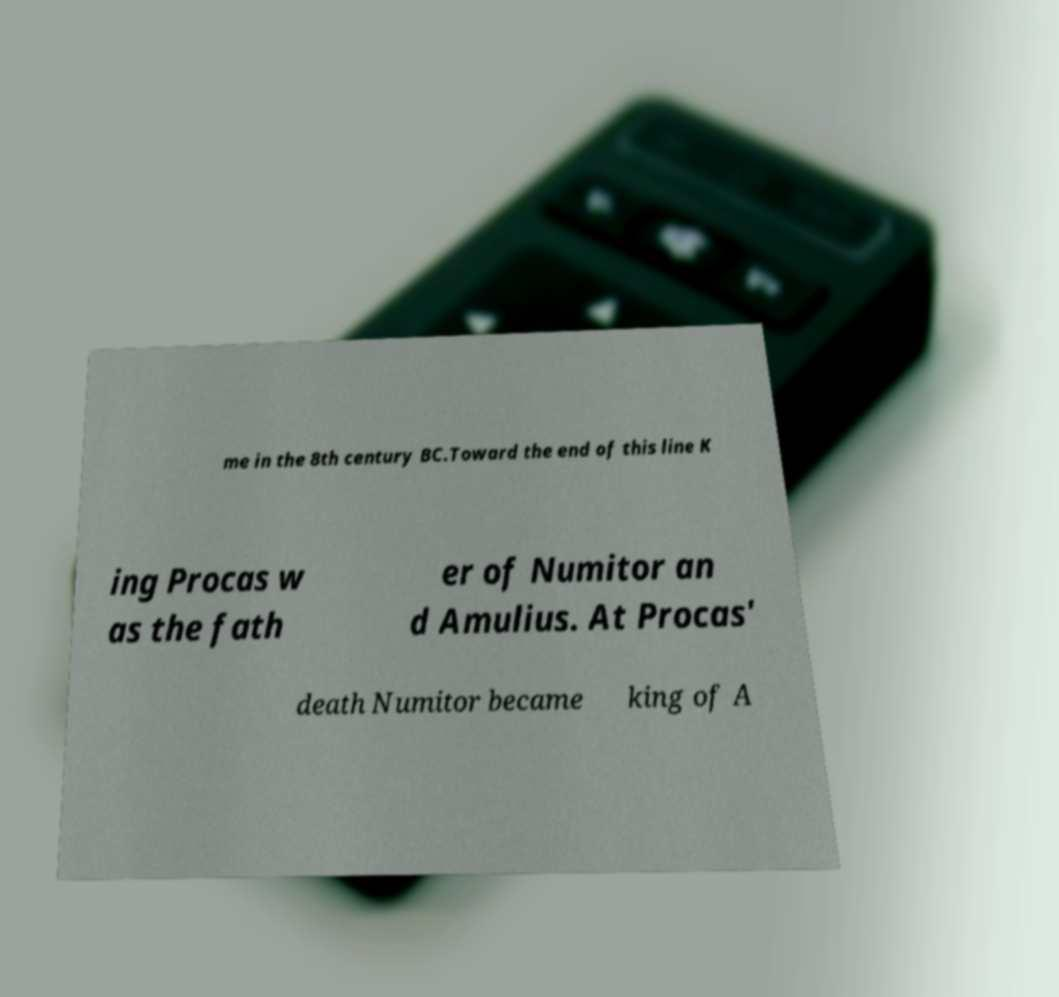Can you read and provide the text displayed in the image?This photo seems to have some interesting text. Can you extract and type it out for me? me in the 8th century BC.Toward the end of this line K ing Procas w as the fath er of Numitor an d Amulius. At Procas' death Numitor became king of A 